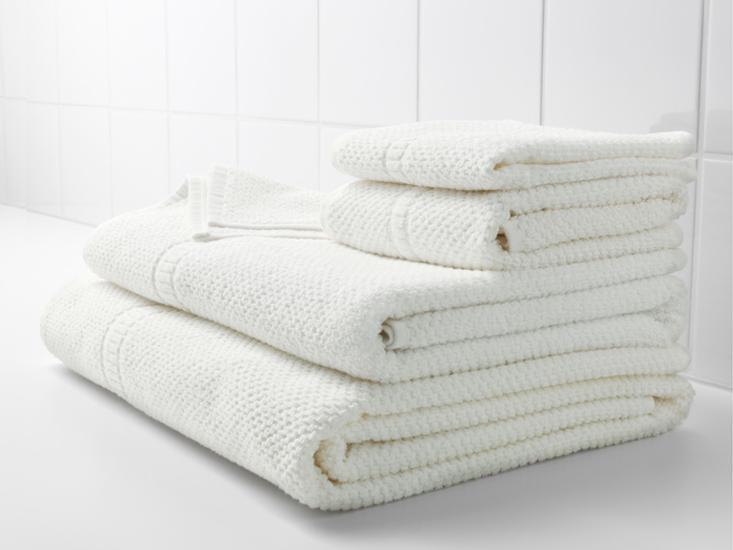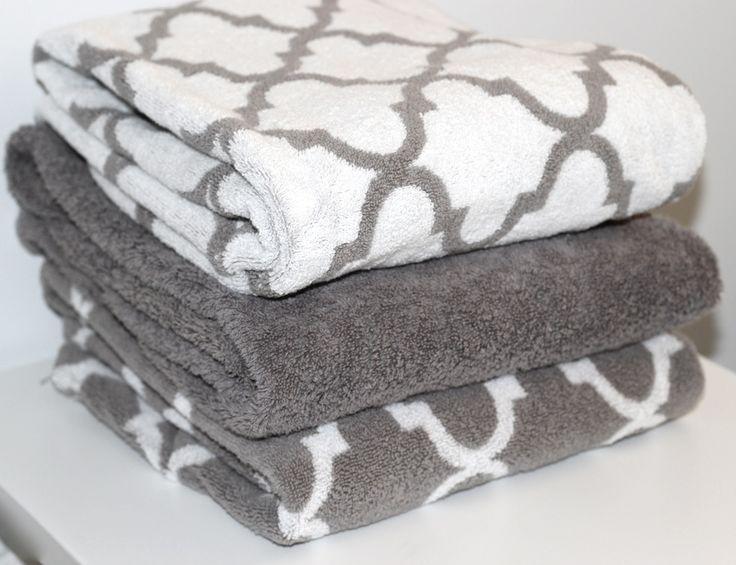The first image is the image on the left, the second image is the image on the right. Examine the images to the left and right. Is the description "One image includes gray and white towels with an all-over pattern." accurate? Answer yes or no. Yes. 